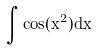Convert formula to latex. <formula><loc_0><loc_0><loc_500><loc_500>\int \cos ( x ^ { 2 } ) d x</formula> 